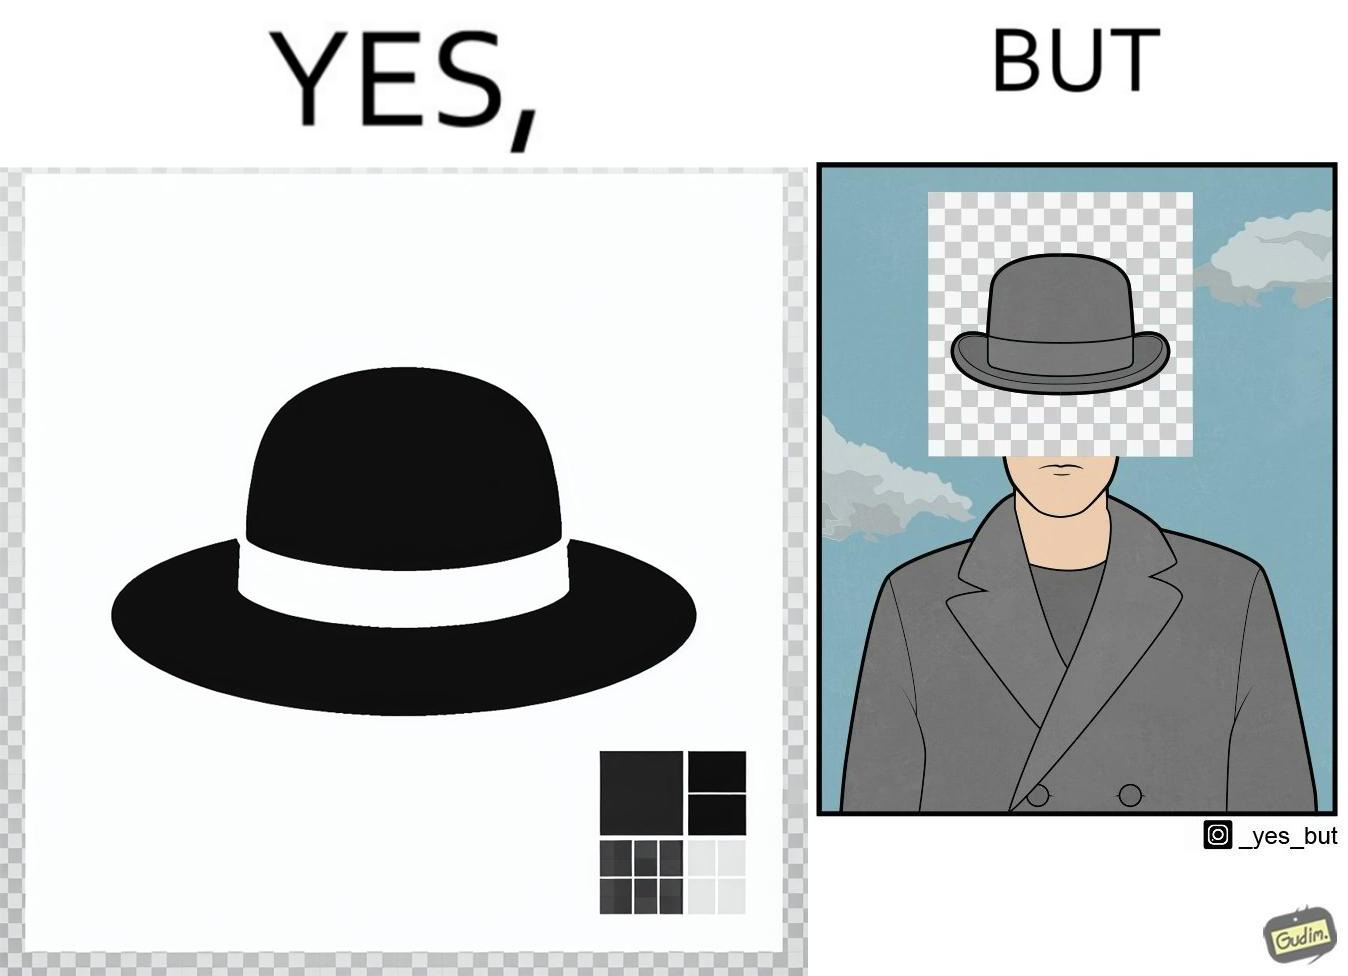Compare the left and right sides of this image. In the left part of the image: It is a .png image of a hat with a transparent background In the right part of the image: It is a man with a hat whose face is covered by a pattern 